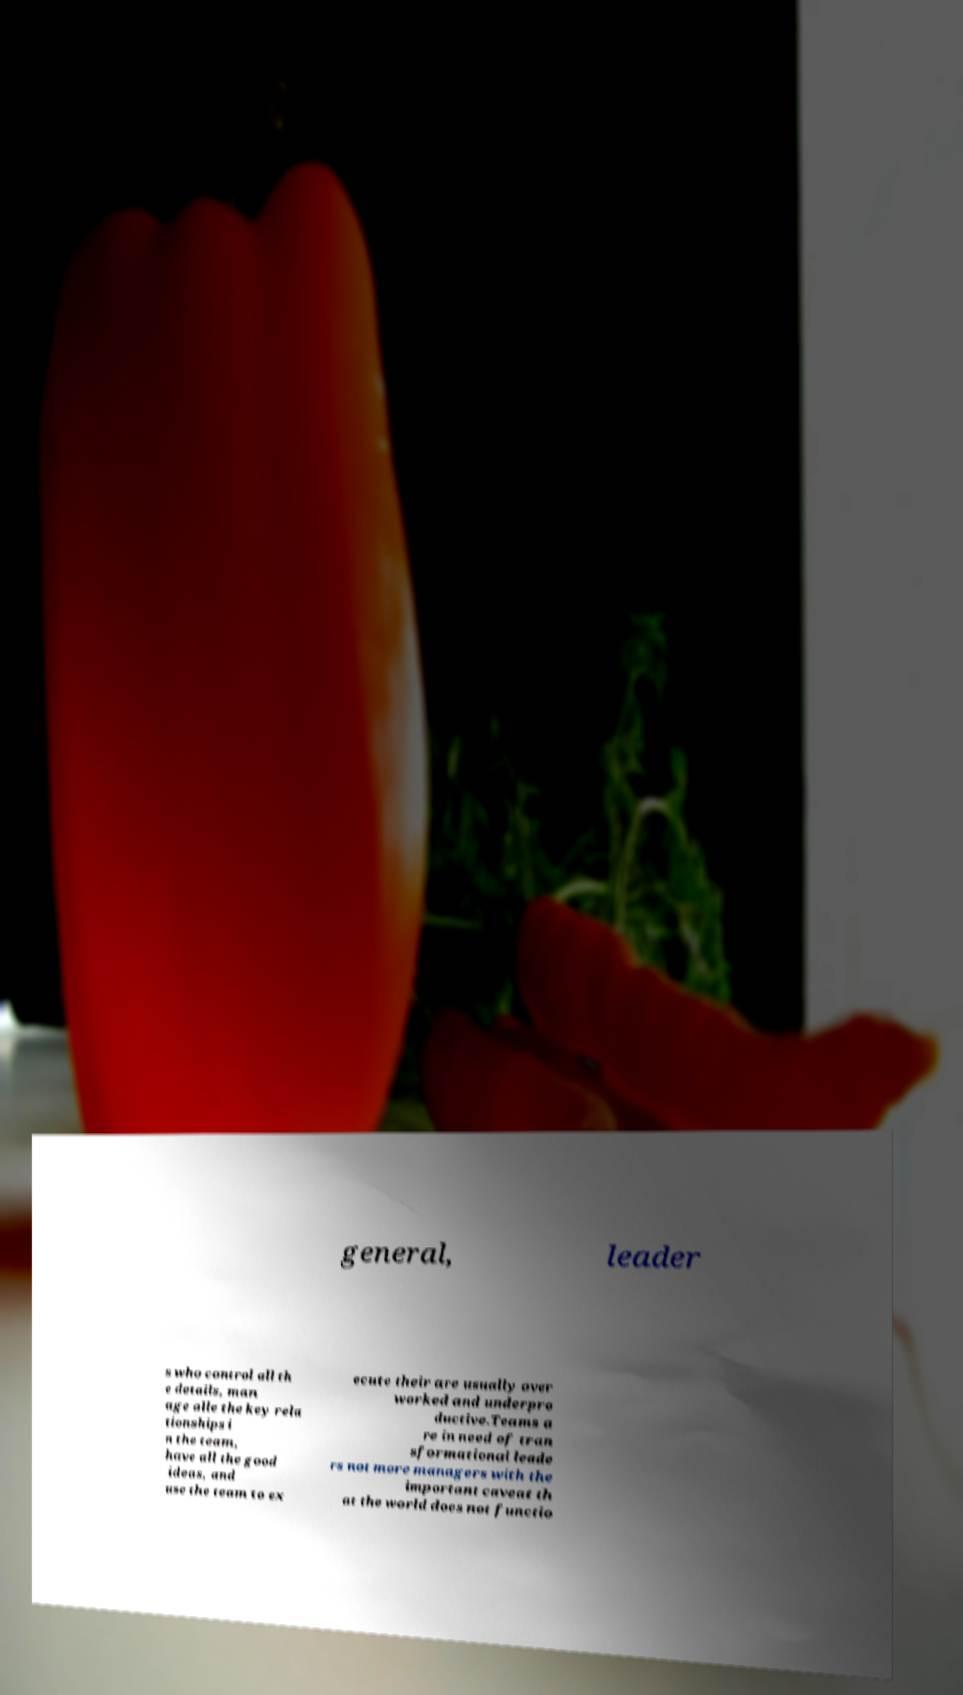For documentation purposes, I need the text within this image transcribed. Could you provide that? general, leader s who control all th e details, man age alle the key rela tionships i n the team, have all the good ideas, and use the team to ex ecute their are usually over worked and underpro ductive.Teams a re in need of tran sformational leade rs not more managers with the important caveat th at the world does not functio 